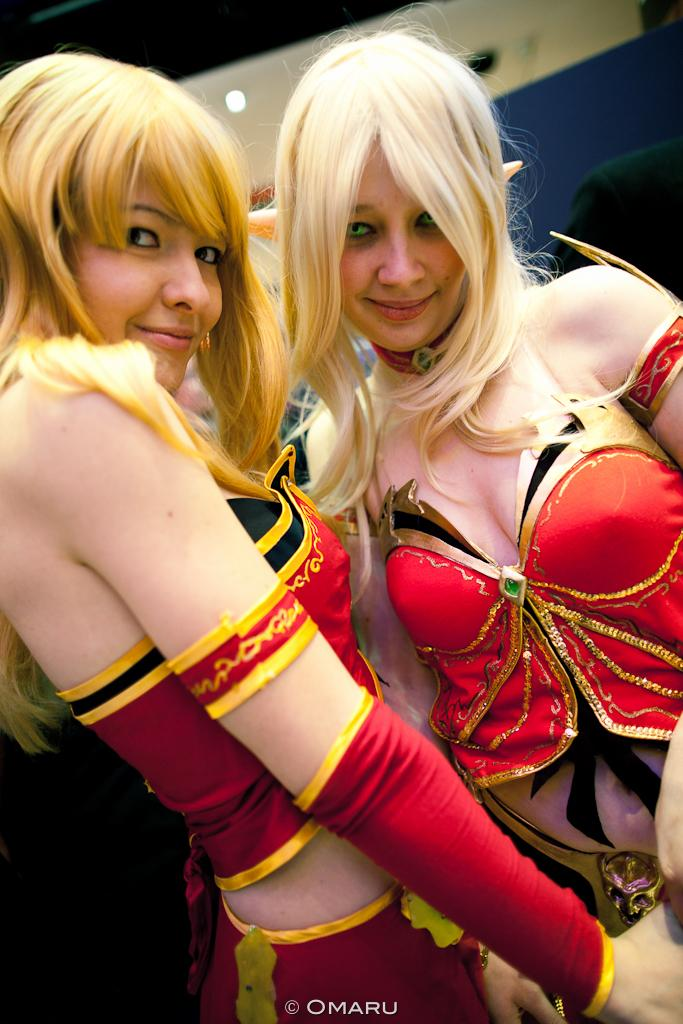How many women are in the image? There are two women in the image. What are the women wearing? Both women are wearing red dresses. What can be seen in the background of the image? There is a light and a wall in the background of the image. Can you tell me how many mittens the girl is wearing in the image? There is no girl present in the image, and therefore no mittens can be observed. 